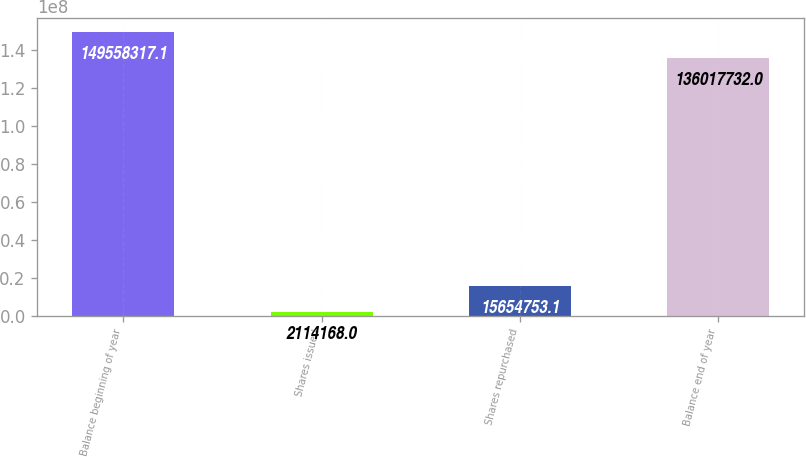Convert chart. <chart><loc_0><loc_0><loc_500><loc_500><bar_chart><fcel>Balance beginning of year<fcel>Shares issued<fcel>Shares repurchased<fcel>Balance end of year<nl><fcel>1.49558e+08<fcel>2.11417e+06<fcel>1.56548e+07<fcel>1.36018e+08<nl></chart> 